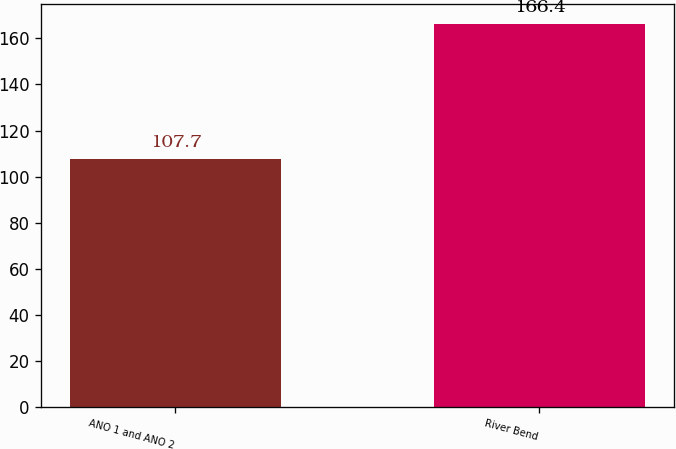Convert chart to OTSL. <chart><loc_0><loc_0><loc_500><loc_500><bar_chart><fcel>ANO 1 and ANO 2<fcel>River Bend<nl><fcel>107.7<fcel>166.4<nl></chart> 